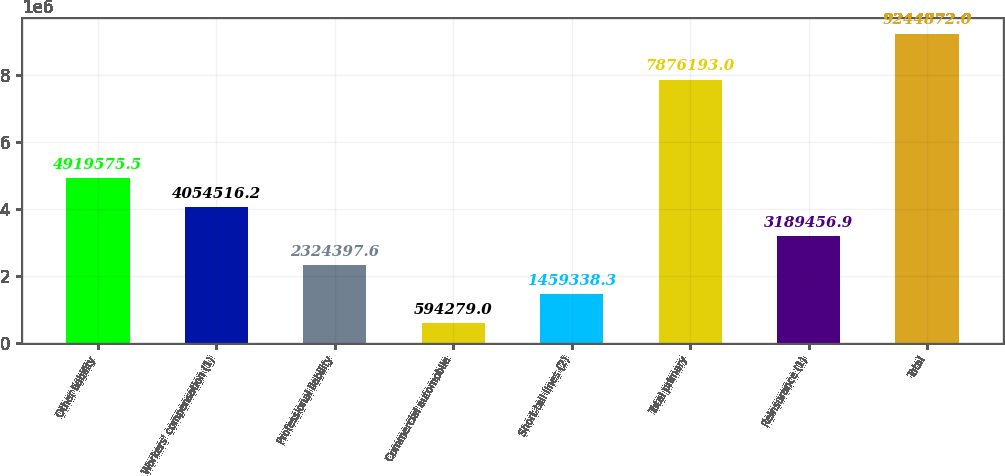Convert chart to OTSL. <chart><loc_0><loc_0><loc_500><loc_500><bar_chart><fcel>Other liability<fcel>Workers' compensation (1)<fcel>Professional liability<fcel>Commercial automobile<fcel>Short-tail lines (2)<fcel>Total primary<fcel>Reinsurance (1)<fcel>Total<nl><fcel>4.91958e+06<fcel>4.05452e+06<fcel>2.3244e+06<fcel>594279<fcel>1.45934e+06<fcel>7.87619e+06<fcel>3.18946e+06<fcel>9.24487e+06<nl></chart> 